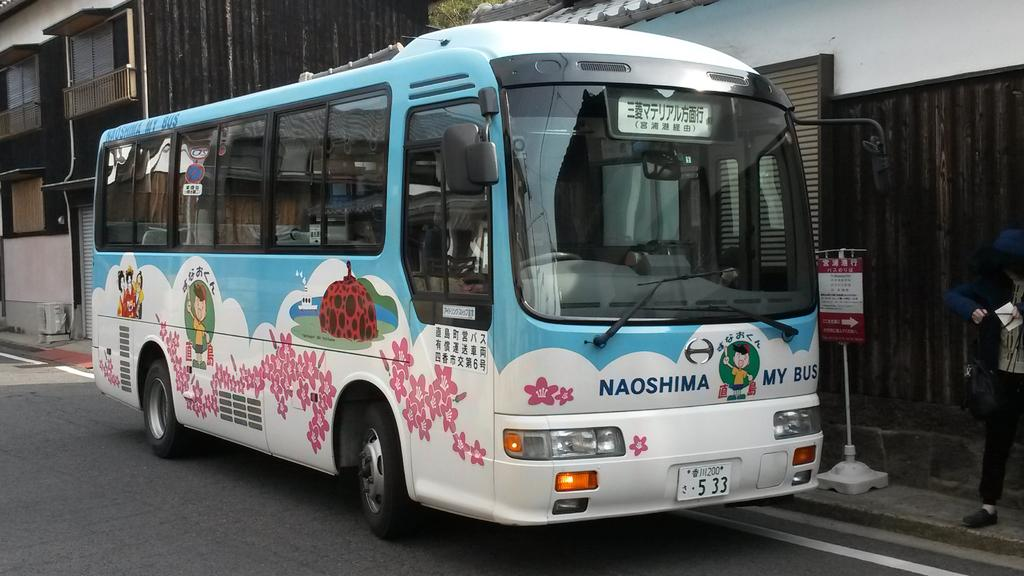What is the main subject of the image? The main subject of the image is a bus. Where is the bus located in the image? The bus is on the road in the image. Can you describe anything else visible in the image? There is a person standing on the right side of the image. What type of nest can be seen in the image? There is no nest present in the image; it features a bus on the road and a person standing on the right side. 